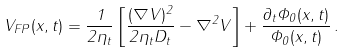<formula> <loc_0><loc_0><loc_500><loc_500>V _ { F P } ( x , t ) = \frac { 1 } { 2 \eta _ { t } } \left [ \frac { ( \nabla V ) ^ { 2 } } { 2 \eta _ { t } D _ { t } } - \nabla ^ { 2 } V \right ] + \frac { \partial _ { t } \Phi _ { 0 } ( x , t ) } { \Phi _ { 0 } ( x , t ) } \, .</formula> 